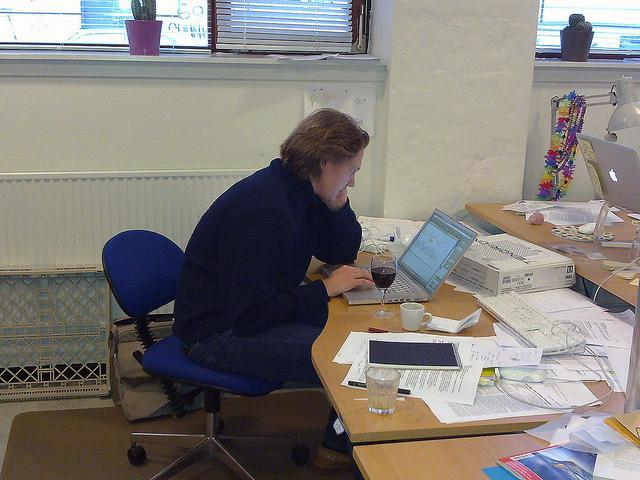Which liquid is most likely to be spilled on a laptop here? Please explain your reasoning. red wine. Because the wine glass is so close to the laptop it is most likely the one in question. 